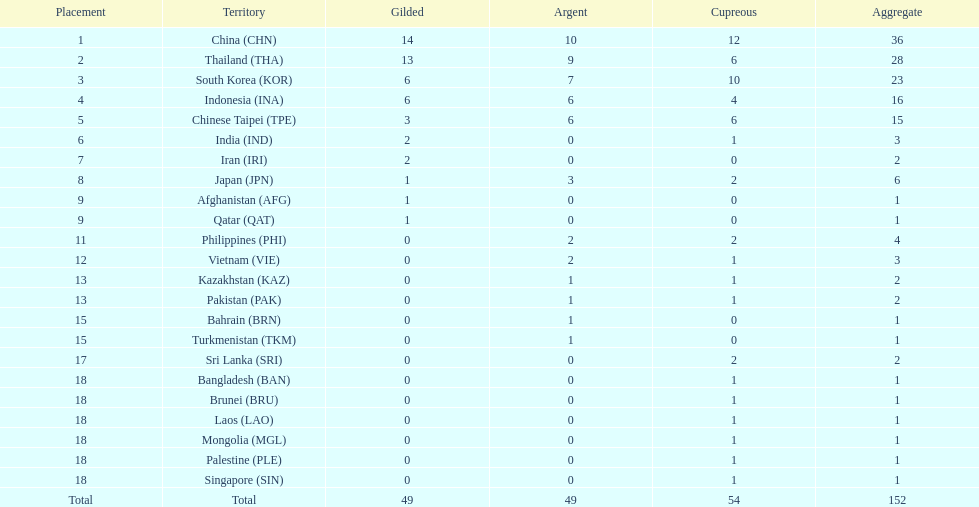Did the philippines or kazakhstan have a higher number of total medals? Philippines. 